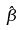<formula> <loc_0><loc_0><loc_500><loc_500>\hat { \beta }</formula> 